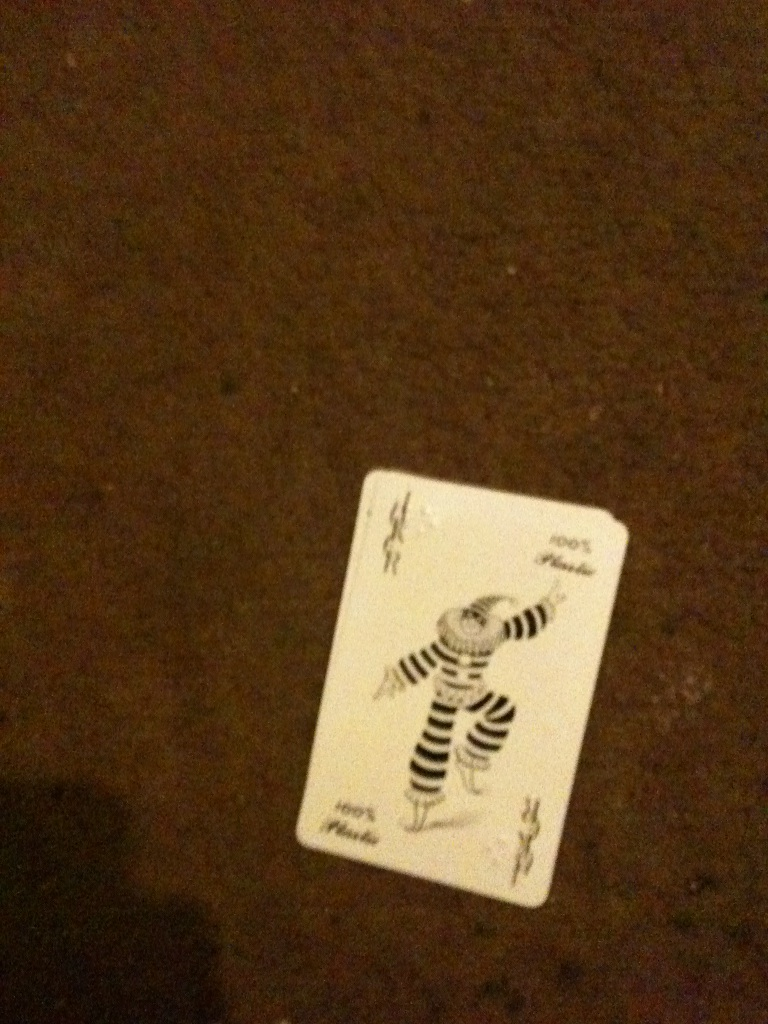Imagine if this Joker card existed in a fantasy world. What kind of powers would this Joker character have? In a fantasy world, the Joker character on this card might possess the power of illusion and laughter. He could conjure illusions to amuse and distract his foes, causing them to see things that aren't there while he moves invisibly. His laughter could be enchanting, with the ability to charm or even heal those who hear it. He might also have a magical staff that allows him to teleport, ensuring he can always deliver his tricks and antics anywhere in the kingdom at a moment's notice. 